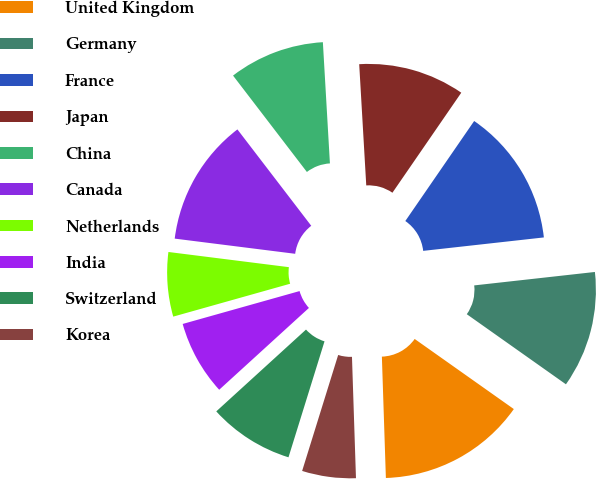Convert chart. <chart><loc_0><loc_0><loc_500><loc_500><pie_chart><fcel>United Kingdom<fcel>Germany<fcel>France<fcel>Japan<fcel>China<fcel>Canada<fcel>Netherlands<fcel>India<fcel>Switzerland<fcel>Korea<nl><fcel>14.68%<fcel>11.56%<fcel>13.64%<fcel>10.52%<fcel>9.48%<fcel>12.6%<fcel>6.36%<fcel>7.4%<fcel>8.44%<fcel>5.32%<nl></chart> 